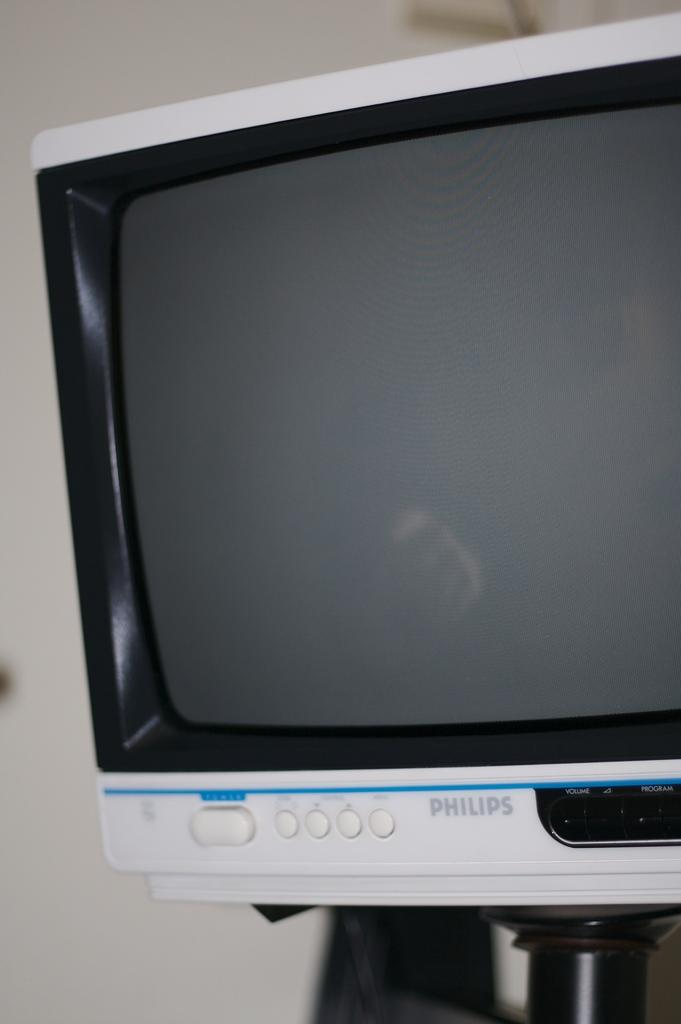What is the main object in the image? There is a television in the image. What color is the television? The television is white in color. What can be seen in the background of the image? There is a white color wall in the background of the image. What type of advertisement is being displayed on the television in the image? There is no advertisement visible on the television in the image, as the facts provided do not mention any content being displayed on the screen. 